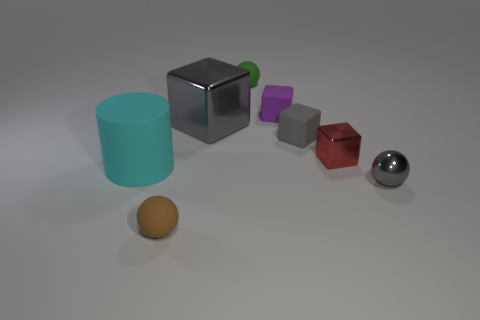What number of objects are either small shiny things behind the gray metallic sphere or objects behind the brown object?
Your answer should be very brief. 7. How many other objects are the same color as the big matte cylinder?
Ensure brevity in your answer.  0. Does the green object behind the tiny brown rubber ball have the same shape as the cyan thing?
Make the answer very short. No. Is the number of tiny gray cubes that are in front of the green sphere less than the number of blue rubber cylinders?
Offer a terse response. No. Is there a small object made of the same material as the green sphere?
Offer a very short reply. Yes. There is a green thing that is the same size as the brown matte ball; what is it made of?
Ensure brevity in your answer.  Rubber. Are there fewer tiny green things that are in front of the big cyan cylinder than tiny blocks that are on the left side of the gray metallic sphere?
Make the answer very short. Yes. There is a thing that is both in front of the large cyan cylinder and on the left side of the tiny shiny block; what is its shape?
Your response must be concise. Sphere. How many other tiny objects have the same shape as the green object?
Your answer should be compact. 2. There is a red cube that is made of the same material as the small gray sphere; what size is it?
Keep it short and to the point. Small. 